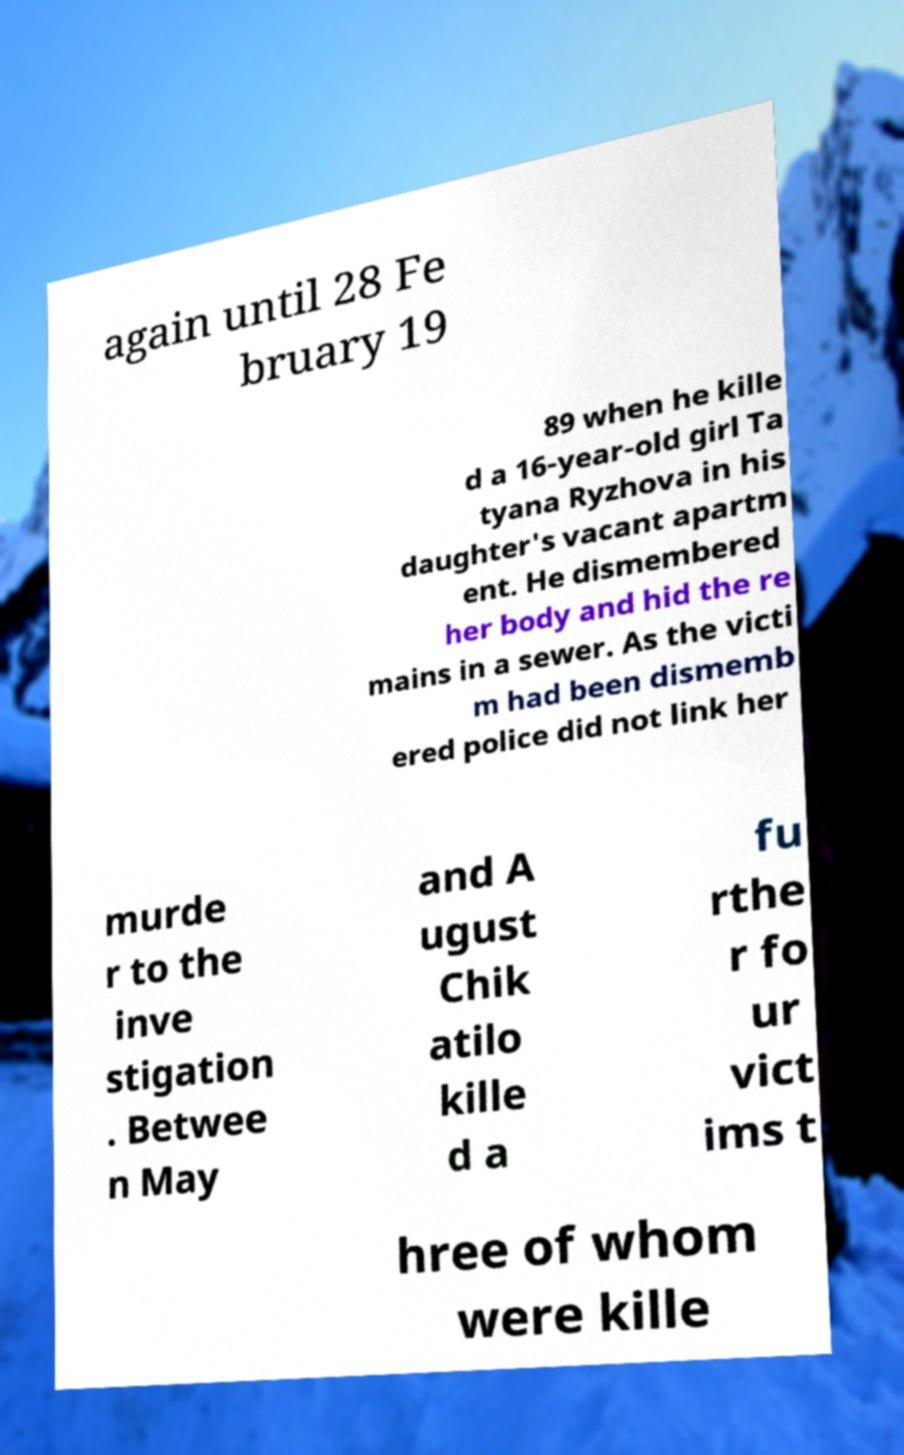Can you read and provide the text displayed in the image?This photo seems to have some interesting text. Can you extract and type it out for me? again until 28 Fe bruary 19 89 when he kille d a 16-year-old girl Ta tyana Ryzhova in his daughter's vacant apartm ent. He dismembered her body and hid the re mains in a sewer. As the victi m had been dismemb ered police did not link her murde r to the inve stigation . Betwee n May and A ugust Chik atilo kille d a fu rthe r fo ur vict ims t hree of whom were kille 